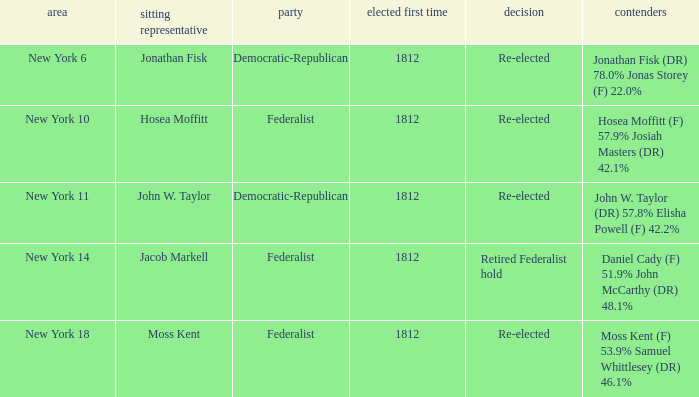Name the least first elected 1812.0. 